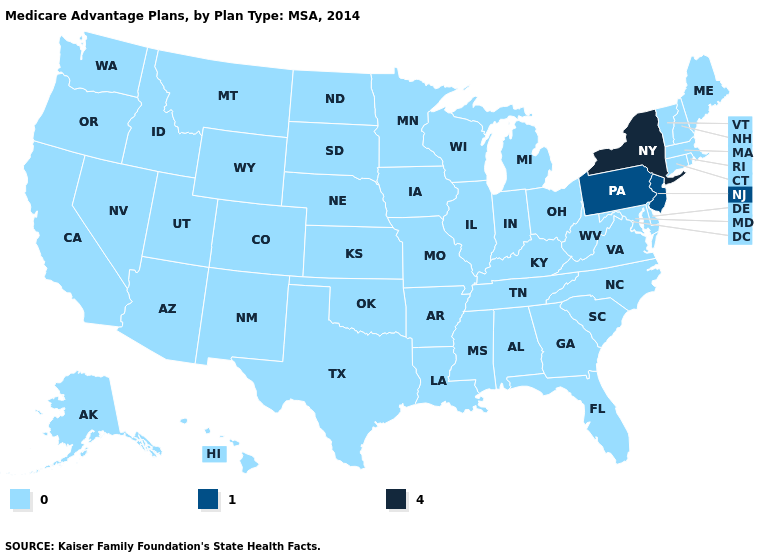What is the highest value in the USA?
Be succinct. 4. What is the value of North Carolina?
Keep it brief. 0. Does New York have the highest value in the USA?
Answer briefly. Yes. Among the states that border South Carolina , which have the lowest value?
Give a very brief answer. Georgia, North Carolina. How many symbols are there in the legend?
Concise answer only. 3. What is the value of Montana?
Give a very brief answer. 0. Name the states that have a value in the range 0?
Keep it brief. Alaska, Alabama, Arkansas, Arizona, California, Colorado, Connecticut, Delaware, Florida, Georgia, Hawaii, Iowa, Idaho, Illinois, Indiana, Kansas, Kentucky, Louisiana, Massachusetts, Maryland, Maine, Michigan, Minnesota, Missouri, Mississippi, Montana, North Carolina, North Dakota, Nebraska, New Hampshire, New Mexico, Nevada, Ohio, Oklahoma, Oregon, Rhode Island, South Carolina, South Dakota, Tennessee, Texas, Utah, Virginia, Vermont, Washington, Wisconsin, West Virginia, Wyoming. Among the states that border Utah , which have the highest value?
Keep it brief. Arizona, Colorado, Idaho, New Mexico, Nevada, Wyoming. What is the value of West Virginia?
Be succinct. 0. Name the states that have a value in the range 4?
Keep it brief. New York. What is the value of Colorado?
Write a very short answer. 0. Which states have the lowest value in the USA?
Be succinct. Alaska, Alabama, Arkansas, Arizona, California, Colorado, Connecticut, Delaware, Florida, Georgia, Hawaii, Iowa, Idaho, Illinois, Indiana, Kansas, Kentucky, Louisiana, Massachusetts, Maryland, Maine, Michigan, Minnesota, Missouri, Mississippi, Montana, North Carolina, North Dakota, Nebraska, New Hampshire, New Mexico, Nevada, Ohio, Oklahoma, Oregon, Rhode Island, South Carolina, South Dakota, Tennessee, Texas, Utah, Virginia, Vermont, Washington, Wisconsin, West Virginia, Wyoming. Does New York have the highest value in the USA?
Short answer required. Yes. Name the states that have a value in the range 1?
Be succinct. New Jersey, Pennsylvania. 